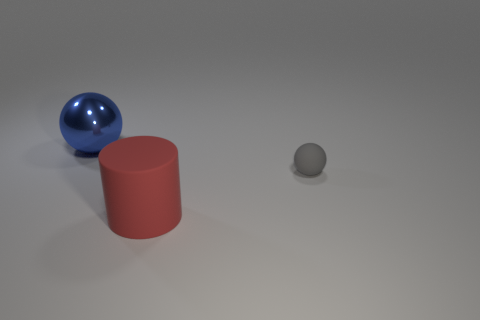Are there any other things that are made of the same material as the blue thing?
Ensure brevity in your answer.  No. Is the size of the object left of the red object the same as the red matte cylinder?
Make the answer very short. Yes. There is another thing that is the same size as the red object; what is its shape?
Provide a short and direct response. Sphere. Does the tiny gray thing have the same shape as the blue metallic object?
Your response must be concise. Yes. How many other things are the same shape as the blue object?
Offer a very short reply. 1. There is a red cylinder; how many big shiny things are behind it?
Offer a very short reply. 1. What number of red things are the same size as the blue shiny thing?
Your response must be concise. 1. What is the shape of the red object that is the same material as the small sphere?
Give a very brief answer. Cylinder. Is there a large matte cylinder of the same color as the large ball?
Ensure brevity in your answer.  No. What is the material of the small gray object?
Your answer should be compact. Rubber. 